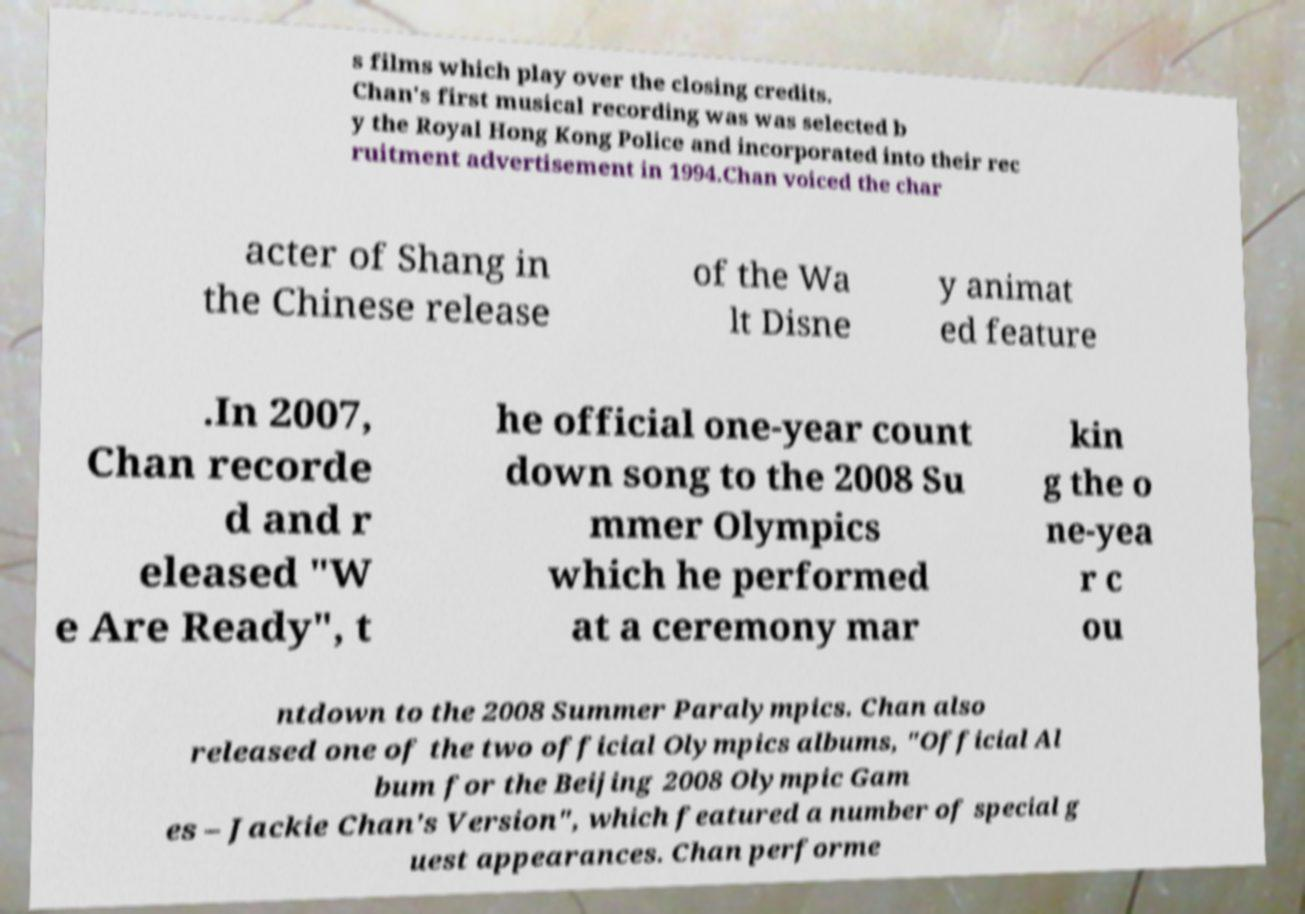Please read and relay the text visible in this image. What does it say? s films which play over the closing credits. Chan's first musical recording was was selected b y the Royal Hong Kong Police and incorporated into their rec ruitment advertisement in 1994.Chan voiced the char acter of Shang in the Chinese release of the Wa lt Disne y animat ed feature .In 2007, Chan recorde d and r eleased "W e Are Ready", t he official one-year count down song to the 2008 Su mmer Olympics which he performed at a ceremony mar kin g the o ne-yea r c ou ntdown to the 2008 Summer Paralympics. Chan also released one of the two official Olympics albums, "Official Al bum for the Beijing 2008 Olympic Gam es – Jackie Chan's Version", which featured a number of special g uest appearances. Chan performe 